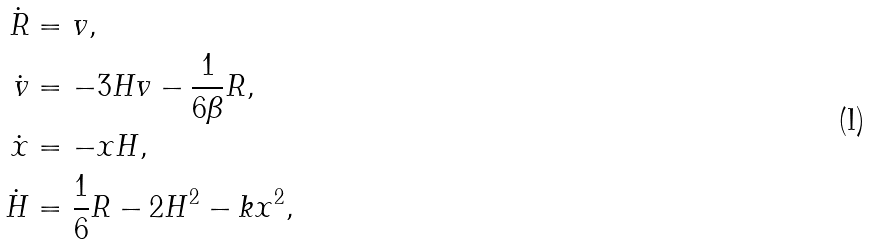<formula> <loc_0><loc_0><loc_500><loc_500>\dot { R } & = v , \\ \dot { v } & = - 3 H v - \frac { 1 } { 6 \beta } R , \\ \dot { x } & = - x H , \\ \dot { H } & = \frac { 1 } { 6 } R - 2 H ^ { 2 } - k x ^ { 2 } ,</formula> 